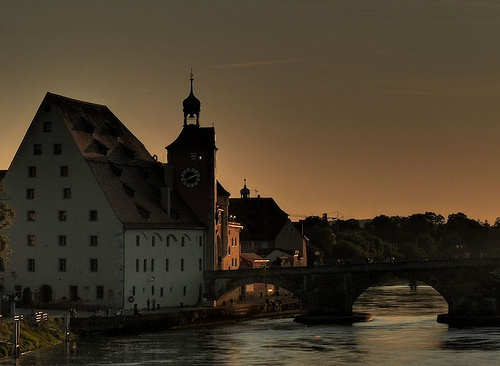Describe the objects in this image and their specific colors. I can see clock in black tones, people in black tones, and people in black tones in this image. 